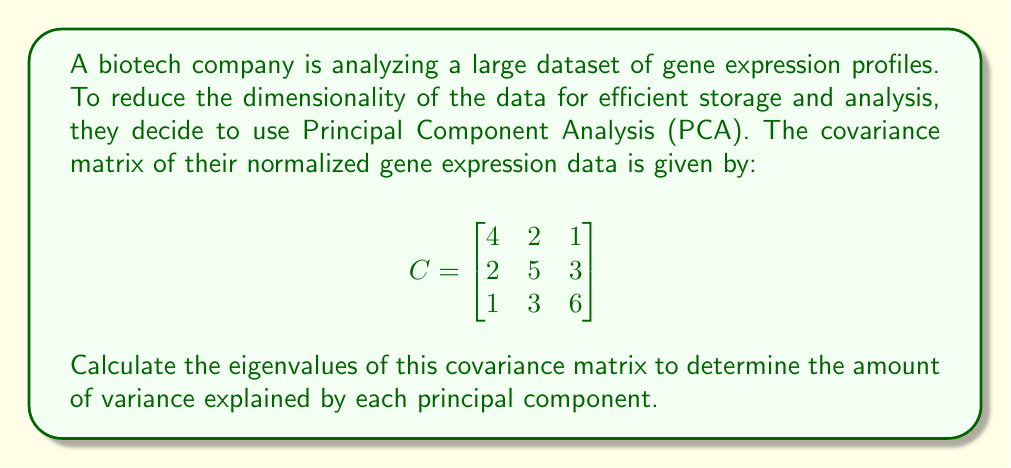Give your solution to this math problem. To find the eigenvalues of the covariance matrix, we need to solve the characteristic equation:

$$\det(C - \lambda I) = 0$$

Where $I$ is the 3x3 identity matrix and $\lambda$ represents the eigenvalues.

Step 1: Set up the characteristic equation:

$$
\det\begin{pmatrix}
4-\lambda & 2 & 1 \\
2 & 5-\lambda & 3 \\
1 & 3 & 6-\lambda
\end{pmatrix} = 0
$$

Step 2: Expand the determinant:

$$(4-\lambda)[(5-\lambda)(6-\lambda) - 9] - 2[2(6-\lambda) - 3] + 1[2(3) - (5-\lambda)]$$
$$= (4-\lambda)(30-11\lambda+\lambda^2-9) - 2(12-2\lambda-3) + (6-5+\lambda)$$
$$= (4-\lambda)(21-11\lambda+\lambda^2) - 2(9-2\lambda) + (1+\lambda)$$
$$= 84-44\lambda+4\lambda^2-21\lambda+11\lambda^2-\lambda^3 - 18+4\lambda + 1+\lambda$$
$$= -\lambda^3 + 15\lambda^2 - 60\lambda + 67$$

Step 3: Solve the cubic equation:

$$\lambda^3 - 15\lambda^2 + 60\lambda - 67 = 0$$

This equation can be solved using various methods such as the cubic formula or numerical methods. The roots of this equation are the eigenvalues of the covariance matrix.

Using a numerical method or a computer algebra system, we find the roots to be:

$$\lambda_1 \approx 8.90$$
$$\lambda_2 \approx 4.76$$
$$\lambda_3 \approx 1.34$$

These eigenvalues represent the variance explained by each principal component, with the largest eigenvalue corresponding to the first principal component, which explains the most variance in the data.
Answer: The eigenvalues of the covariance matrix are approximately:
$$\lambda_1 \approx 8.90$$
$$\lambda_2 \approx 4.76$$
$$\lambda_3 \approx 1.34$$ 